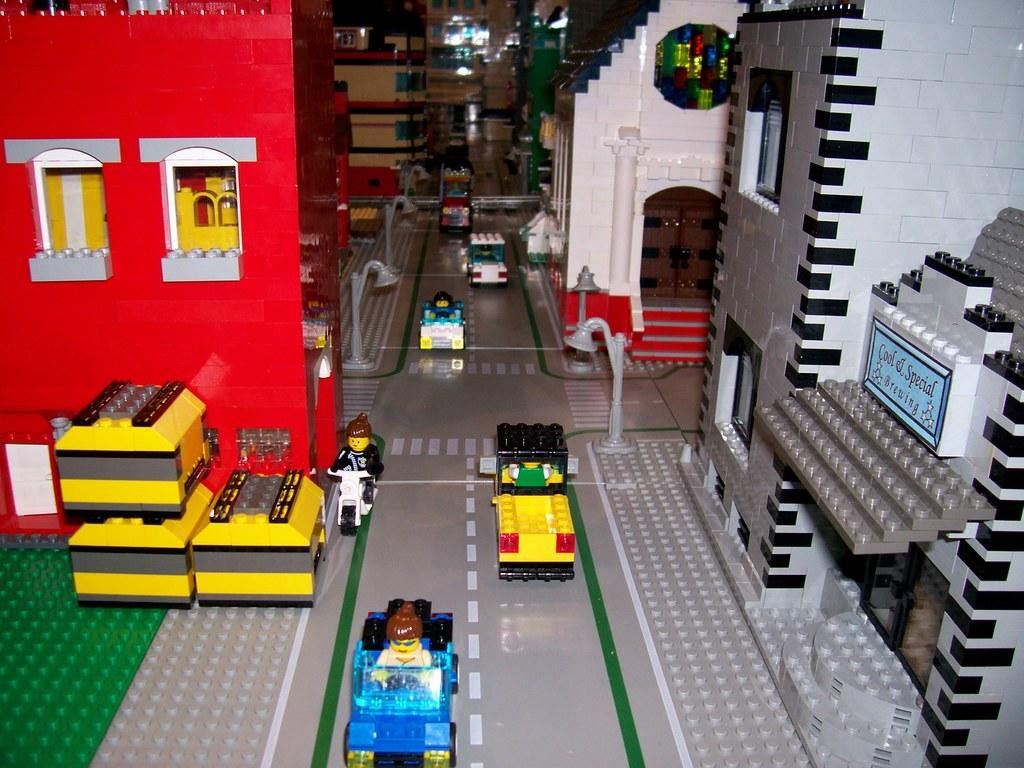What type of toys are present in the image? There are toy buildings, toy vehicles, toy persons, and toy street lights in the image. Can you describe the toy vehicles in the image? The toy vehicles in the image are likely meant to represent cars, trucks, or other forms of transportation. What other types of toys are interacting with the toy vehicles in the image? The toy persons are interacting with the toy vehicles in the image. Are there any other types of structures or objects in the image besides the toy buildings? Yes, there are toy street lights in the image. What type of rhythm do the toy dolls dance to in the image? There are no toy dolls present in the image, so there is no rhythm for them to dance to. 